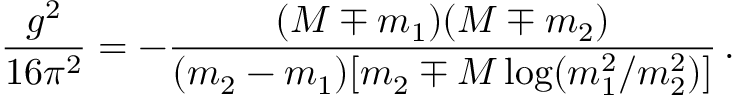Convert formula to latex. <formula><loc_0><loc_0><loc_500><loc_500>\frac { g ^ { 2 } } { 1 6 \pi ^ { 2 } } = - \frac { ( M \mp m _ { 1 } ) ( M \mp m _ { 2 } ) } { ( m _ { 2 } - m _ { 1 } ) [ m _ { 2 } \mp M \log ( m _ { 1 } ^ { 2 } / m _ { 2 } ^ { 2 } ) ] } \, .</formula> 